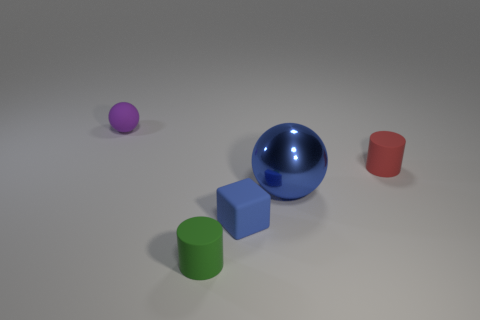Add 5 green blocks. How many objects exist? 10 Subtract all cylinders. How many objects are left? 3 Subtract 0 blue cylinders. How many objects are left? 5 Subtract all small purple matte cylinders. Subtract all green matte objects. How many objects are left? 4 Add 2 big metallic objects. How many big metallic objects are left? 3 Add 1 big brown shiny cubes. How many big brown shiny cubes exist? 1 